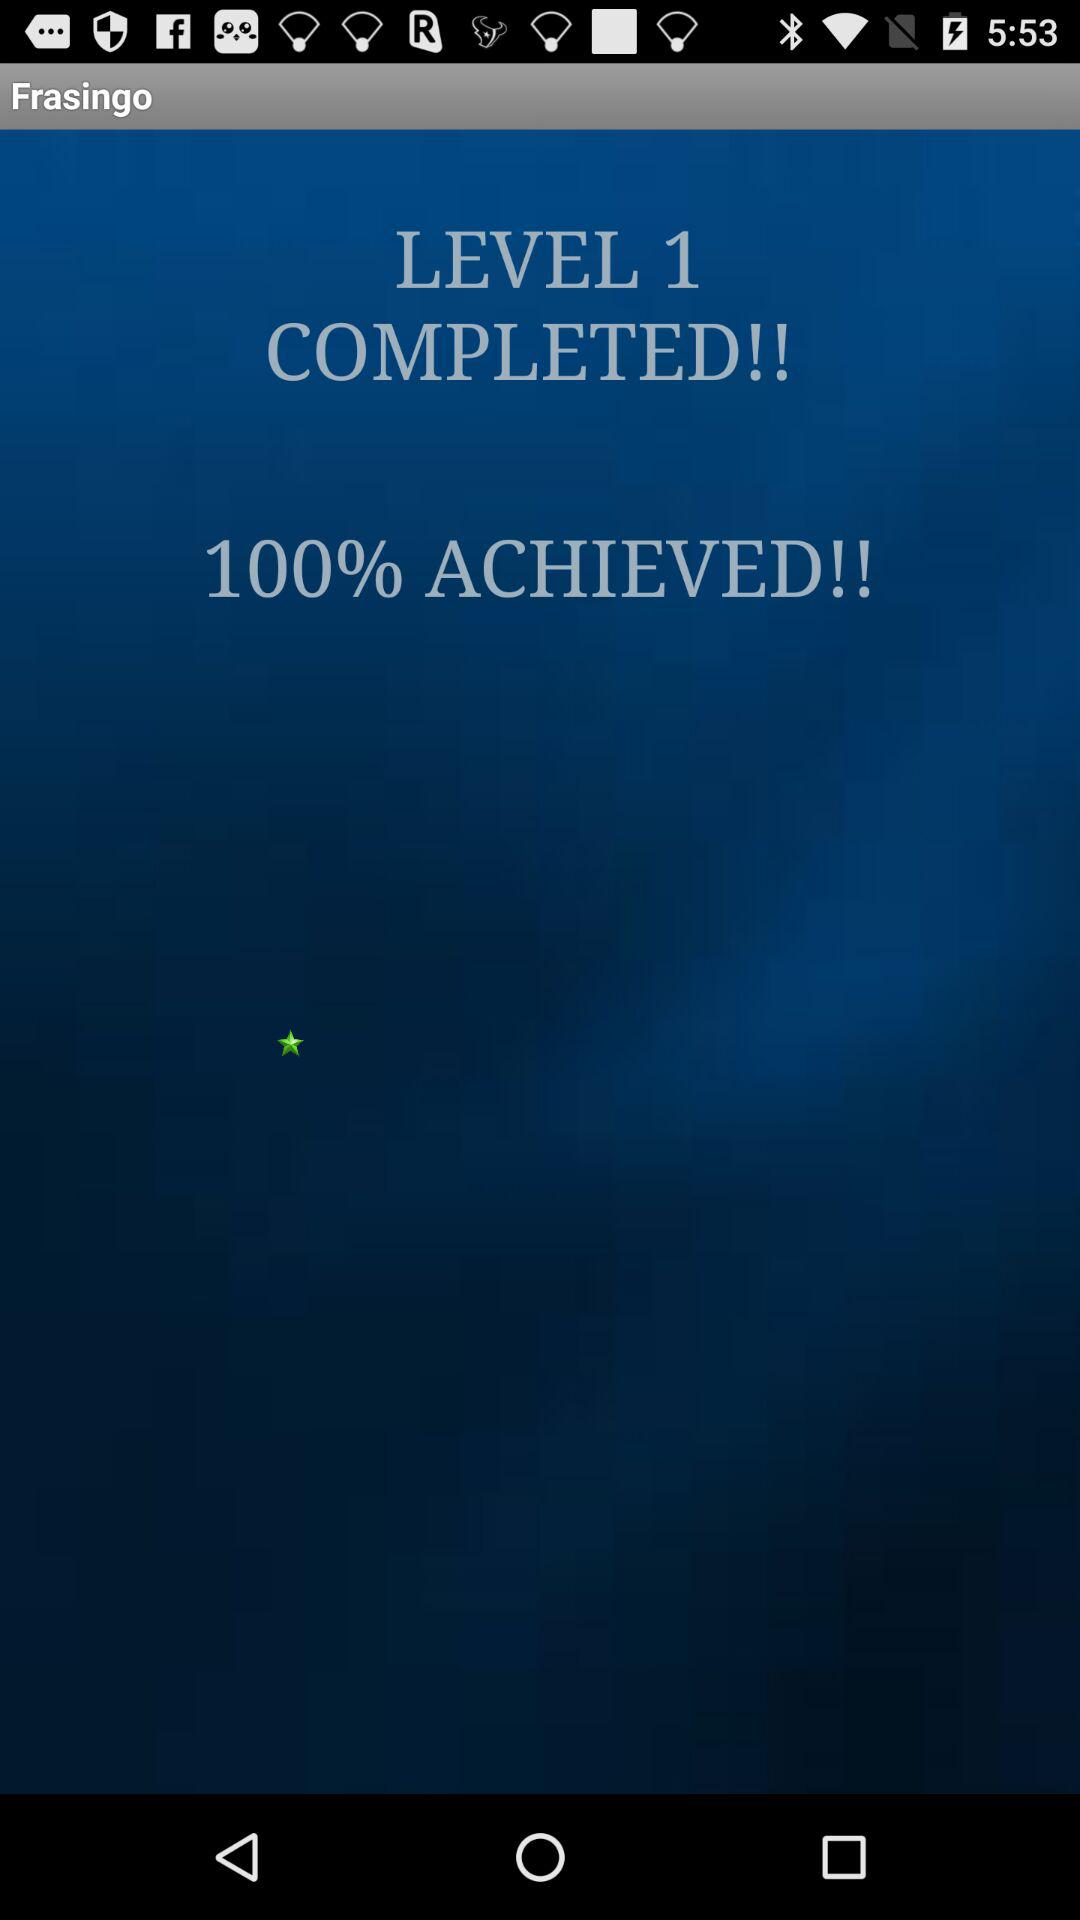How much did we achieve?
Answer the question using a single word or phrase. You achieved 100%. 